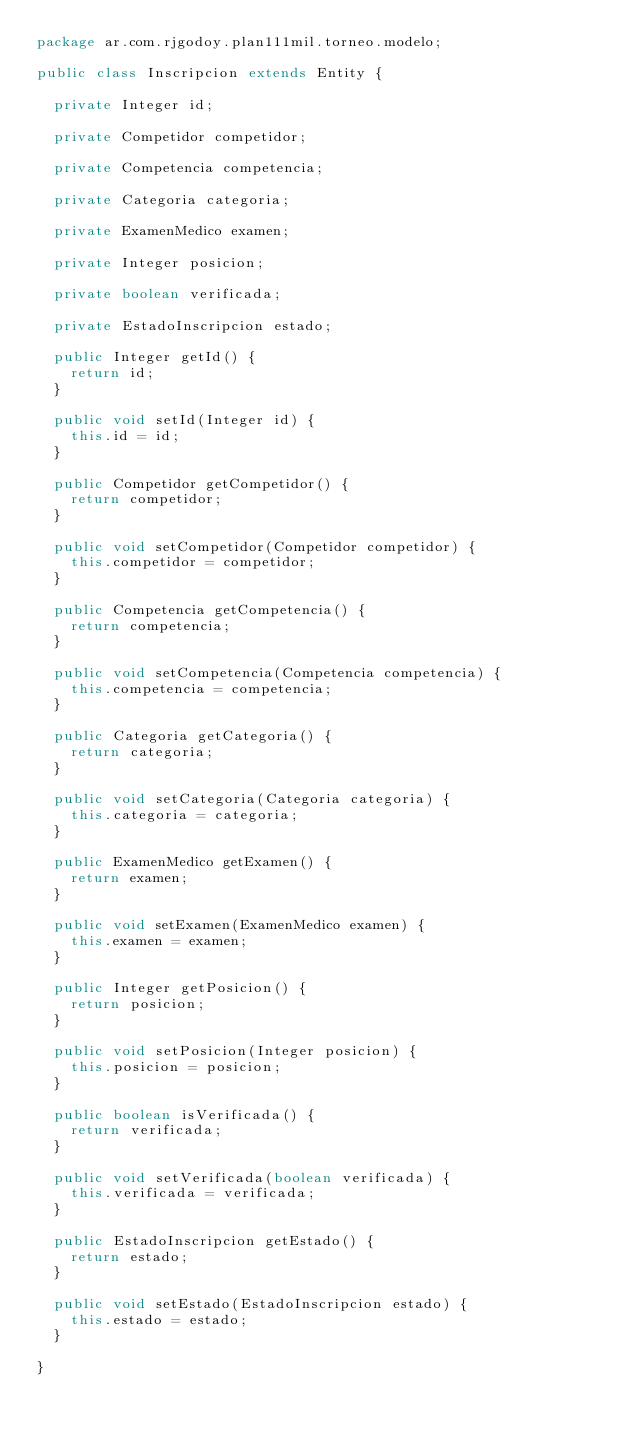<code> <loc_0><loc_0><loc_500><loc_500><_Java_>package ar.com.rjgodoy.plan111mil.torneo.modelo;

public class Inscripcion extends Entity {

	private Integer id;

	private Competidor competidor;
	
	private Competencia competencia;
	
	private Categoria categoria;

	private ExamenMedico examen;

	private Integer posicion;

	private boolean verificada;

	private EstadoInscripcion estado;

	public Integer getId() {
		return id;
	}

	public void setId(Integer id) {
		this.id = id;
	}

	public Competidor getCompetidor() {
		return competidor;
	}

	public void setCompetidor(Competidor competidor) {
		this.competidor = competidor;
	}

	public Competencia getCompetencia() {
		return competencia;
	}

	public void setCompetencia(Competencia competencia) {
		this.competencia = competencia;
	}

	public Categoria getCategoria() {
		return categoria;
	}

	public void setCategoria(Categoria categoria) {
		this.categoria = categoria;
	}

	public ExamenMedico getExamen() {
		return examen;
	}

	public void setExamen(ExamenMedico examen) {
		this.examen = examen;
	}

	public Integer getPosicion() {
		return posicion;
	}

	public void setPosicion(Integer posicion) {
		this.posicion = posicion;
	}

	public boolean isVerificada() {
		return verificada;
	}

	public void setVerificada(boolean verificada) {
		this.verificada = verificada;
	}

	public EstadoInscripcion getEstado() {
		return estado;
	}

	public void setEstado(EstadoInscripcion estado) {
		this.estado = estado;
	}

}
</code> 